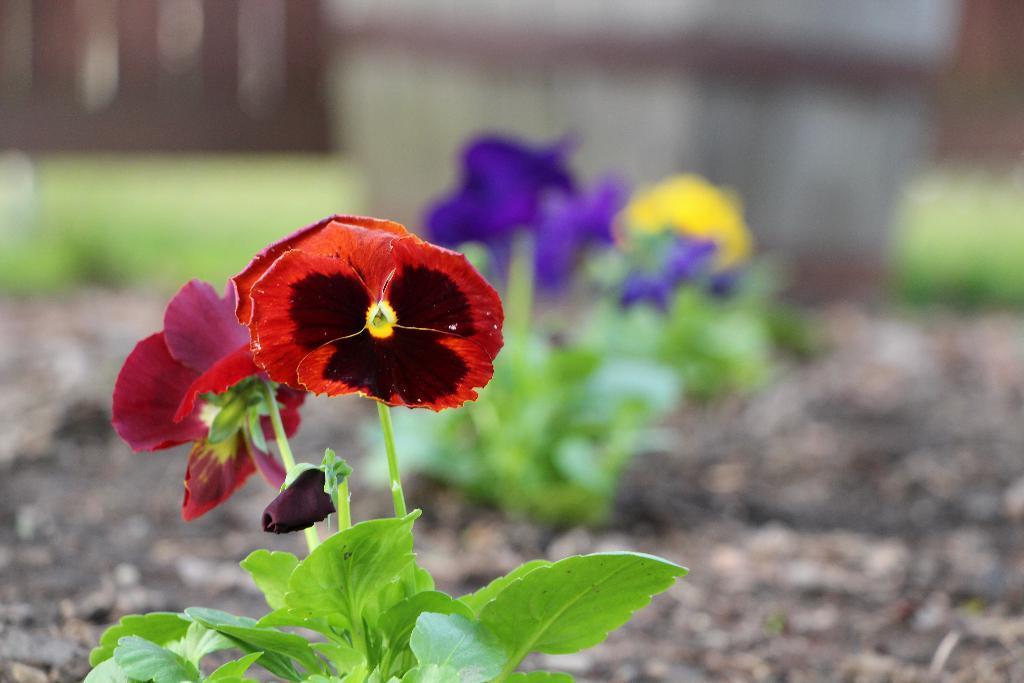Can you describe this image briefly? At the bottom of this image, there is a plant having flowers and green color leaves. And the background is blurred. 